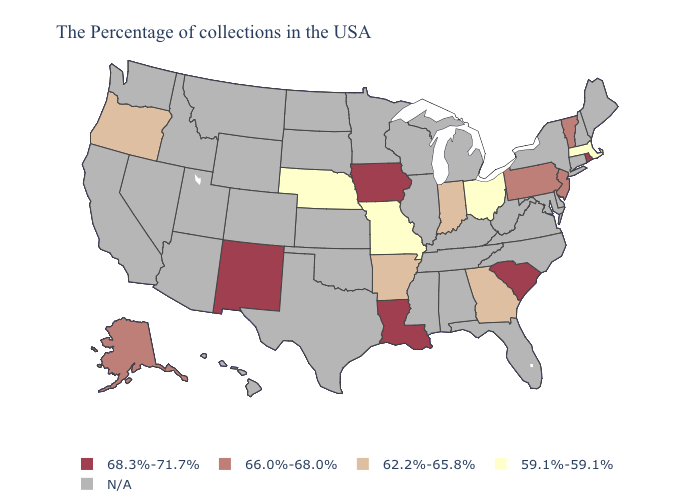What is the value of Florida?
Write a very short answer. N/A. What is the highest value in the West ?
Keep it brief. 68.3%-71.7%. Which states have the highest value in the USA?
Write a very short answer. Rhode Island, South Carolina, Louisiana, Iowa, New Mexico. Name the states that have a value in the range 62.2%-65.8%?
Quick response, please. Georgia, Indiana, Arkansas, Oregon. Which states have the highest value in the USA?
Short answer required. Rhode Island, South Carolina, Louisiana, Iowa, New Mexico. What is the value of Florida?
Keep it brief. N/A. What is the highest value in the USA?
Keep it brief. 68.3%-71.7%. Does the map have missing data?
Give a very brief answer. Yes. What is the value of Arizona?
Quick response, please. N/A. Name the states that have a value in the range N/A?
Answer briefly. Maine, New Hampshire, Connecticut, New York, Delaware, Maryland, Virginia, North Carolina, West Virginia, Florida, Michigan, Kentucky, Alabama, Tennessee, Wisconsin, Illinois, Mississippi, Minnesota, Kansas, Oklahoma, Texas, South Dakota, North Dakota, Wyoming, Colorado, Utah, Montana, Arizona, Idaho, Nevada, California, Washington, Hawaii. Name the states that have a value in the range 66.0%-68.0%?
Short answer required. Vermont, New Jersey, Pennsylvania, Alaska. What is the highest value in the South ?
Keep it brief. 68.3%-71.7%. What is the value of Ohio?
Give a very brief answer. 59.1%-59.1%. 